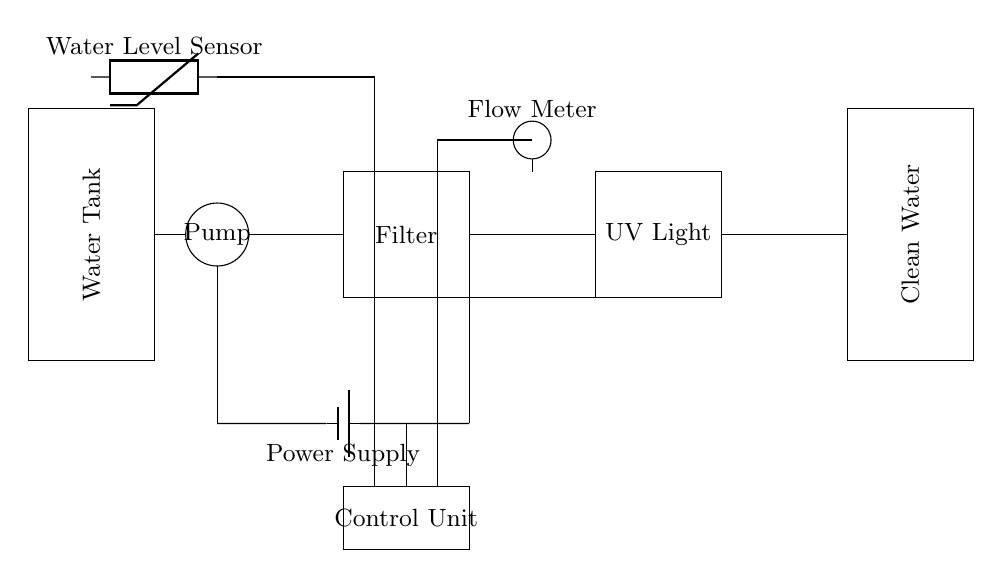What is the primary function of the pump? The pump's primary function is to move water from the water tank to the filter. This is determined by its position between the water tank and the filter, showing its role in the flow of water through the purification system.
Answer: Move water What components are connected to the power supply? The components connected to the power supply are the pump, filter, and UV light. The connections visibly show that these components derive power from the same source, which is indicated in the diagram.
Answer: Pump, filter, UV light What type of sensor is depicted in the circuit? The circuit diagram shows a water level sensor. This can be identified by the symbol used for the sensor, which is explicitly labeled in the diagram, indicating its function.
Answer: Water level sensor What does the flow meter measure? The flow meter measures the flow of water through the system, as indicated by its placement in the circuit and its specific label. It is intended to provide feedback on the volume or rate of water being processed.
Answer: Flow rate Which component disinfects the water? The component that disinfects the water is the UV light. This can be answered by recognizing its role in the purification process, as labeled in the diagram.
Answer: UV light How many tanks are in the system? There are two tanks in the system, a water tank for sourcing water and a clean water tank for storing purified water. Both tanks are labeled distinctly, making the count straightforward.
Answer: Two What is the purpose of the control unit? The control unit regulates the operation of the pump, filter, and UV light for efficient purification. Its position in the circuit signifies its role in managing the whole process.
Answer: Regulation 